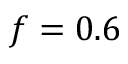Convert formula to latex. <formula><loc_0><loc_0><loc_500><loc_500>f = 0 . 6</formula> 